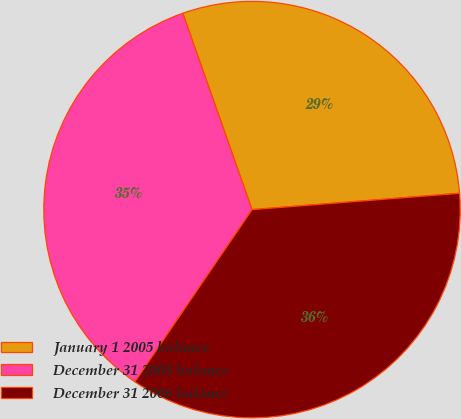Convert chart to OTSL. <chart><loc_0><loc_0><loc_500><loc_500><pie_chart><fcel>January 1 2005 balance<fcel>December 31 2005 balance<fcel>December 31 2006 balance<nl><fcel>29.15%<fcel>35.1%<fcel>35.76%<nl></chart> 